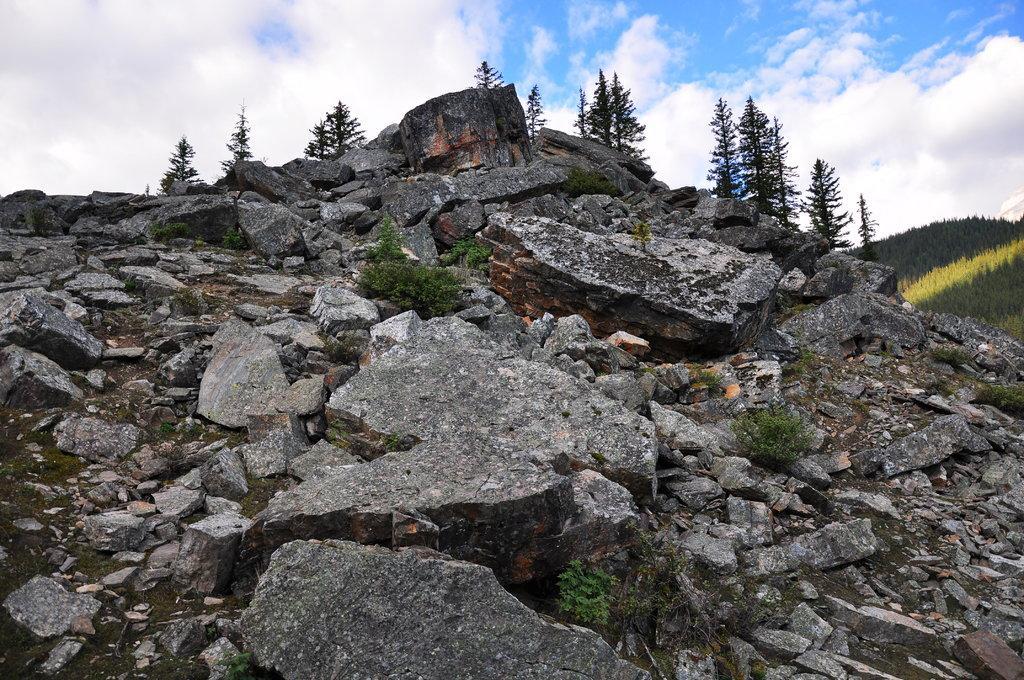How would you summarize this image in a sentence or two? There are few rocks which has few plants in between in it and there are greenery mountains in the right corner. 